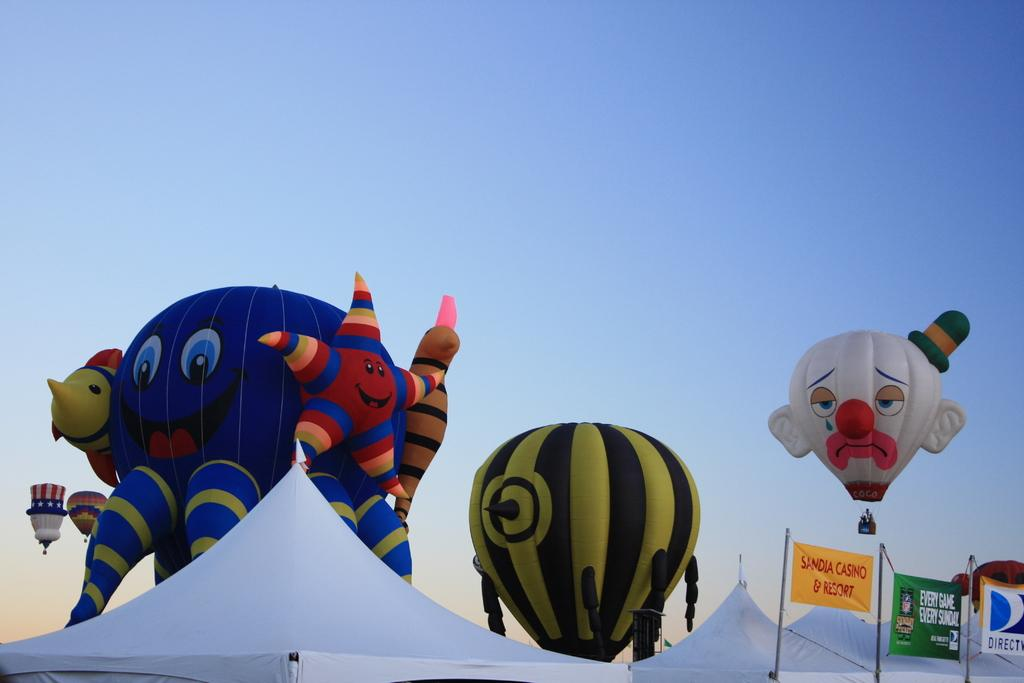What type of structures are present in the image? There are white tents in the image. What other objects can be seen in the image? There are inflatable objects in the image. Where are the posters located in the image? The posters are on the right side of the image. What is the color of the sky in the image? The sky is blue and visible at the top of the image. What type of hall can be seen in the image? There is no hall present in the image; it features white tents, inflatable objects, posters, and a blue sky. What color is the range of mountains in the image? There are no mountains present in the image, so it is not possible to determine the color of any range. 